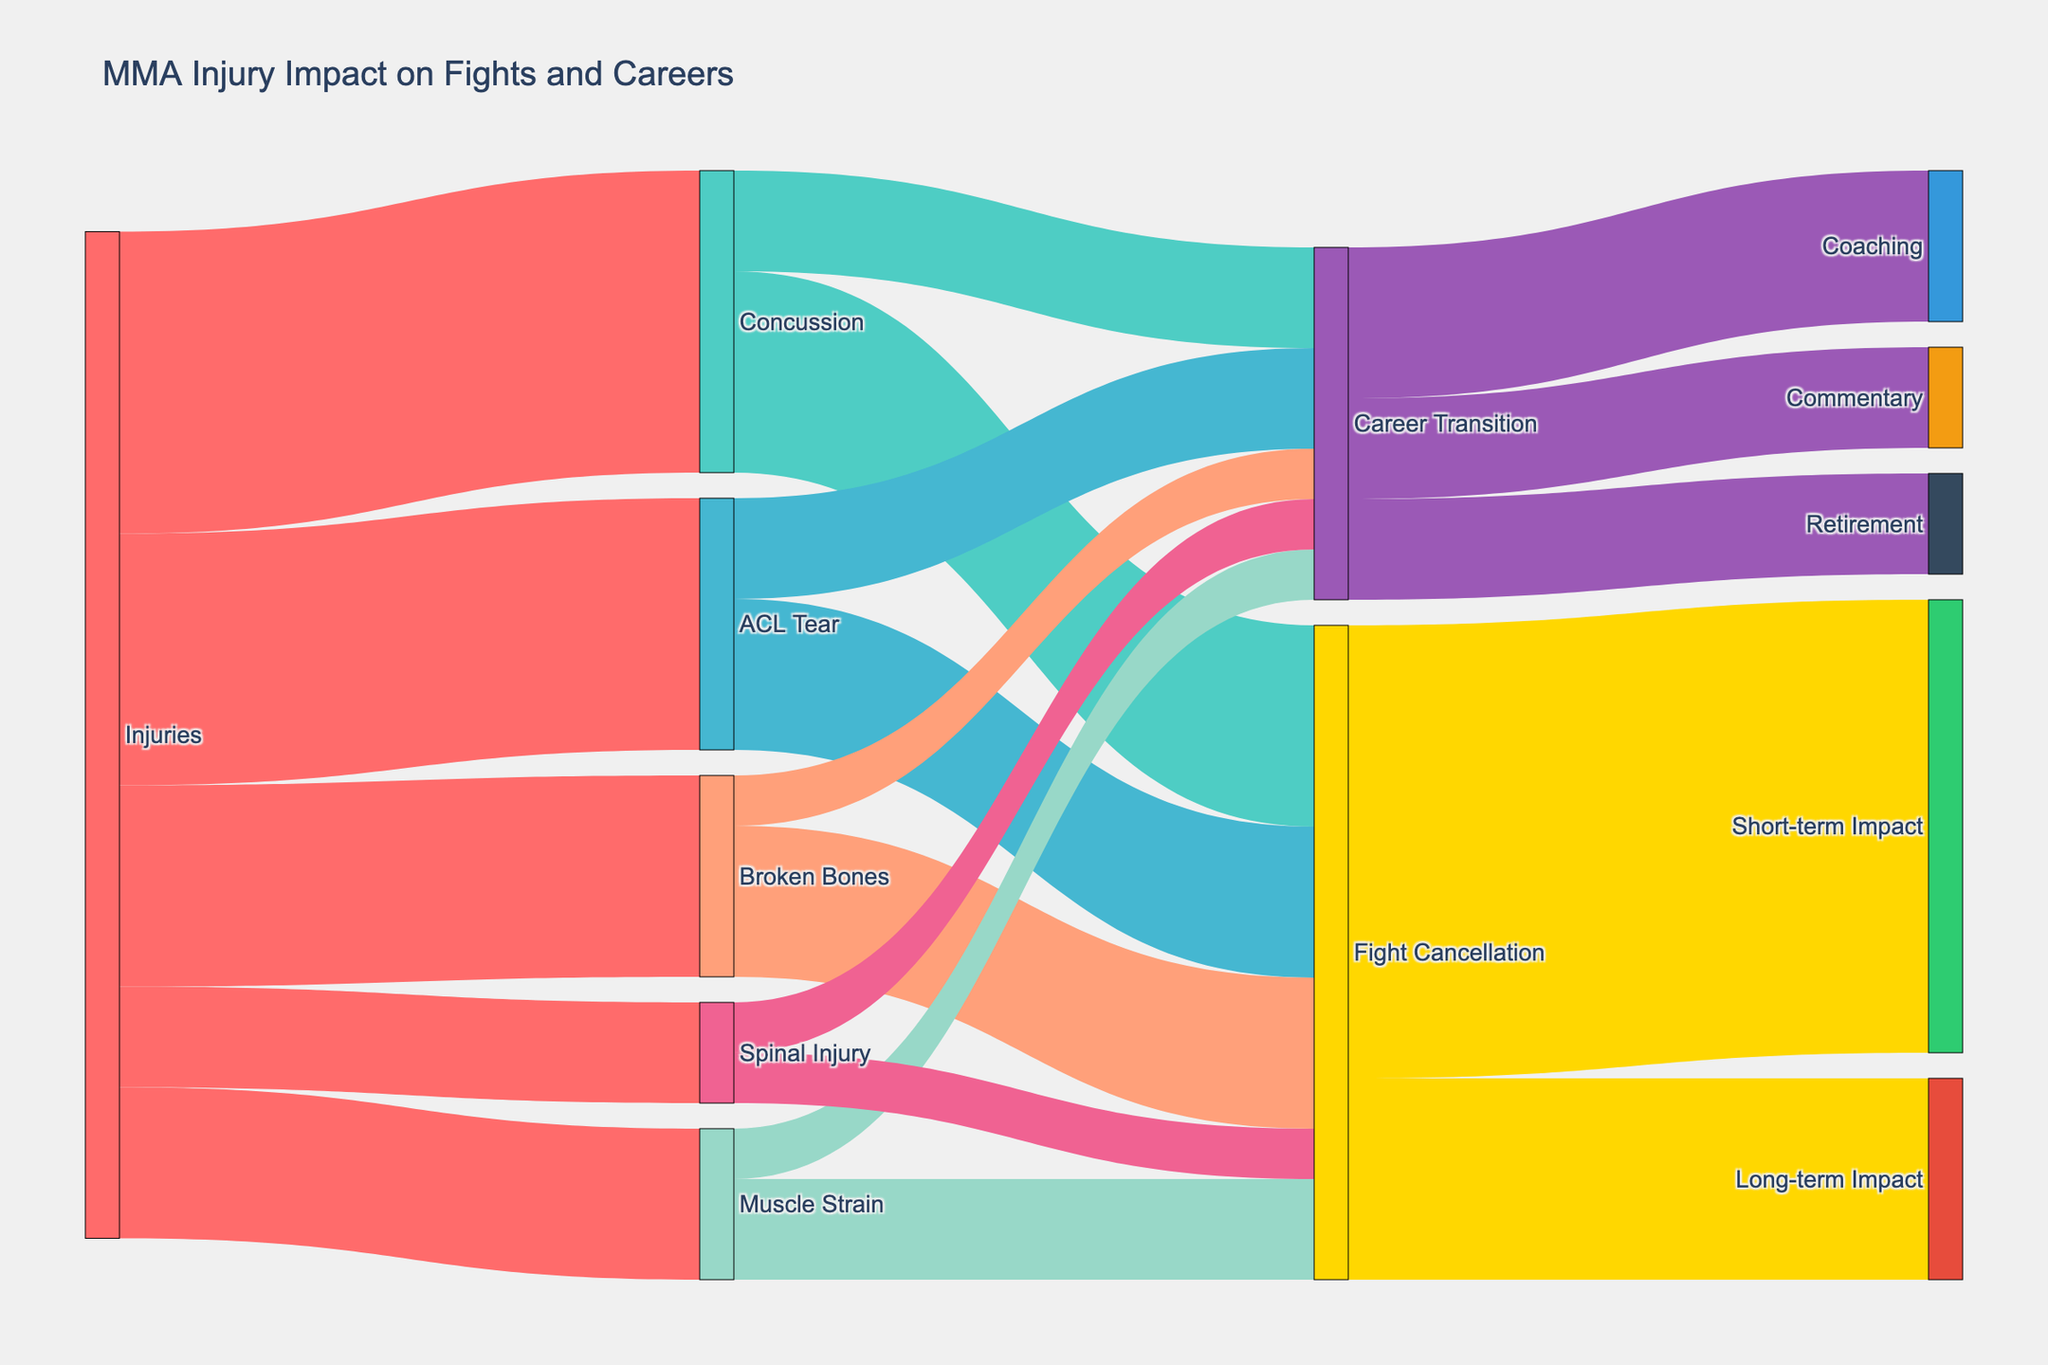How many types of injuries are shown in the diagram? The diagram shows all nodes connected to the "Injuries" node, indicating different types of injuries. There are five nodes connected: Concussion, ACL Tear, Broken Bones, Muscle Strain, and Spinal Injury.
Answer: 5 Which injury leads to the highest number of fight cancellations? By following the flow from each injury to "Fight Cancellation," we can see that Concussion leads to 20 fight cancellations, the highest number.
Answer: Concussion What is the total impact on fights resulting from "Broken Bones"? To find the total impact, add the number of Fight Cancellations and Career Transitions due to Broken Bones. According to the diagram, fight cancellations are 15, and career transitions are 5. Summing them up gives 15 + 5.
Answer: 20 Which career transition is most common for fighters with concussions? Follow the flow from "Concussion" to "Career Transition" nodes. The diagram shows 10 for Career Transition split into Coaching (15), Commentary (10), and Retirement (10). Coaching has the highest value.
Answer: Coaching How does the impact of ACL Tear on career transitions compare with its impact on fight cancellations? The diagram shows that ACL Tear leads to 15 fight cancellations and 10 career transitions. Thus, ACL Tear leads to more cancellations than transitions.
Answer: More cancellations What percentage of fight cancellations lead to long-term impacts? To get the percentage, divide the number of Long-term Impact by the total number of Fight Cancellations and multiply by 100. The Long-term Impact is 20, and the total Fight Cancellations is 45. \(\frac{20}{45} \times 100 = 44.44\%\).
Answer: 44.44% How many career transitions lead to commentary roles? Follow the node from "Career Transition" to "Commentary". The diagram shows an arrow with the value of 10.
Answer: 10 What is the most common outcome of spinal injuries in terms of fight cancellations or career transitions? Following the flow from Spinal Injury, both Fight Cancellation and Career Transition have equal values of 5.
Answer: Equal Which is greater: the number of short-term or long-term impacts resulting from fight cancellations? Compare the values from "Fight Cancellation" to "Short-term Impact" and "Long-term Impact." Short-term has 45, Long-term has 20. So, short-term is greater.
Answer: Short-term How many total impacts (both fight cancellations and career transitions) result from muscle strains? Add the numbers for Fight Cancellations and Career Transitions due to Muscle Strain. The diagram shows 10 for Fight Cancellations and 5 for Career Transitions. Sum them up is 10 + 5.
Answer: 15 